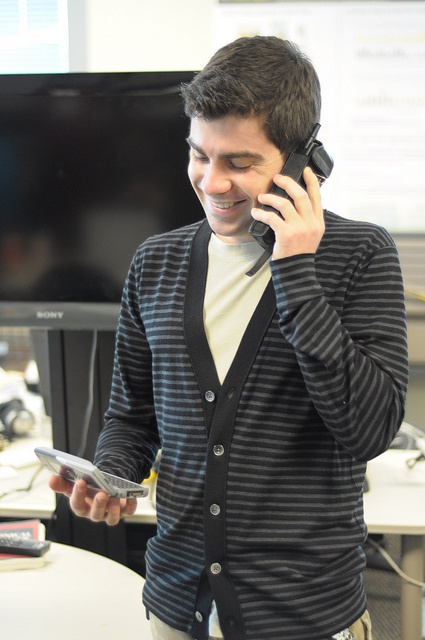Describe the objects in this image and their specific colors. I can see people in white, black, gray, beige, and tan tones, tv in white, black, and gray tones, tv in white, gray, ivory, black, and darkgray tones, cell phone in white, gray, black, and darkgray tones, and cell phone in white, darkgray, lightgray, gray, and beige tones in this image. 